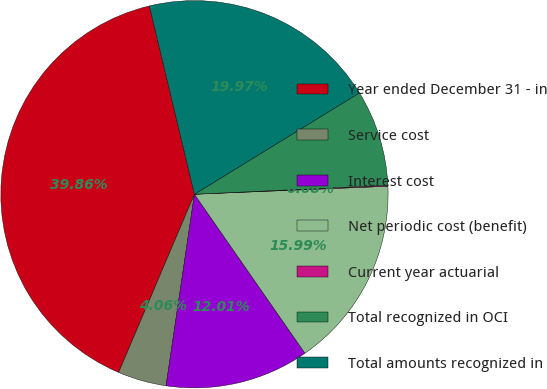Convert chart to OTSL. <chart><loc_0><loc_0><loc_500><loc_500><pie_chart><fcel>Year ended December 31 - in<fcel>Service cost<fcel>Interest cost<fcel>Net periodic cost (benefit)<fcel>Current year actuarial<fcel>Total recognized in OCI<fcel>Total amounts recognized in<nl><fcel>39.86%<fcel>4.06%<fcel>12.01%<fcel>15.99%<fcel>0.08%<fcel>8.03%<fcel>19.97%<nl></chart> 